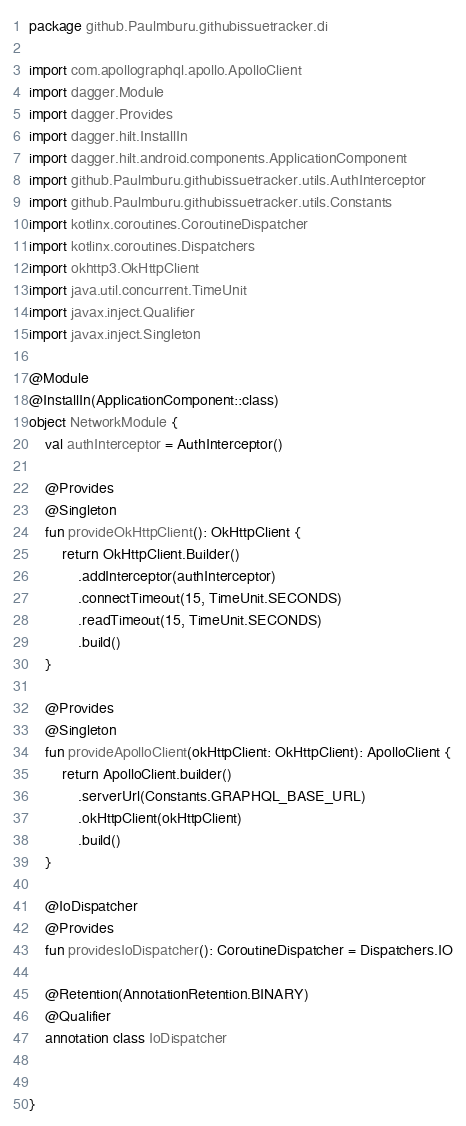Convert code to text. <code><loc_0><loc_0><loc_500><loc_500><_Kotlin_>package github.Paulmburu.githubissuetracker.di

import com.apollographql.apollo.ApolloClient
import dagger.Module
import dagger.Provides
import dagger.hilt.InstallIn
import dagger.hilt.android.components.ApplicationComponent
import github.Paulmburu.githubissuetracker.utils.AuthInterceptor
import github.Paulmburu.githubissuetracker.utils.Constants
import kotlinx.coroutines.CoroutineDispatcher
import kotlinx.coroutines.Dispatchers
import okhttp3.OkHttpClient
import java.util.concurrent.TimeUnit
import javax.inject.Qualifier
import javax.inject.Singleton

@Module
@InstallIn(ApplicationComponent::class)
object NetworkModule {
    val authInterceptor = AuthInterceptor()

    @Provides
    @Singleton
    fun provideOkHttpClient(): OkHttpClient {
        return OkHttpClient.Builder()
            .addInterceptor(authInterceptor)
            .connectTimeout(15, TimeUnit.SECONDS)
            .readTimeout(15, TimeUnit.SECONDS)
            .build()
    }

    @Provides
    @Singleton
    fun provideApolloClient(okHttpClient: OkHttpClient): ApolloClient {
        return ApolloClient.builder()
            .serverUrl(Constants.GRAPHQL_BASE_URL)
            .okHttpClient(okHttpClient)
            .build()
    }

    @IoDispatcher
    @Provides
    fun providesIoDispatcher(): CoroutineDispatcher = Dispatchers.IO

    @Retention(AnnotationRetention.BINARY)
    @Qualifier
    annotation class IoDispatcher


}</code> 